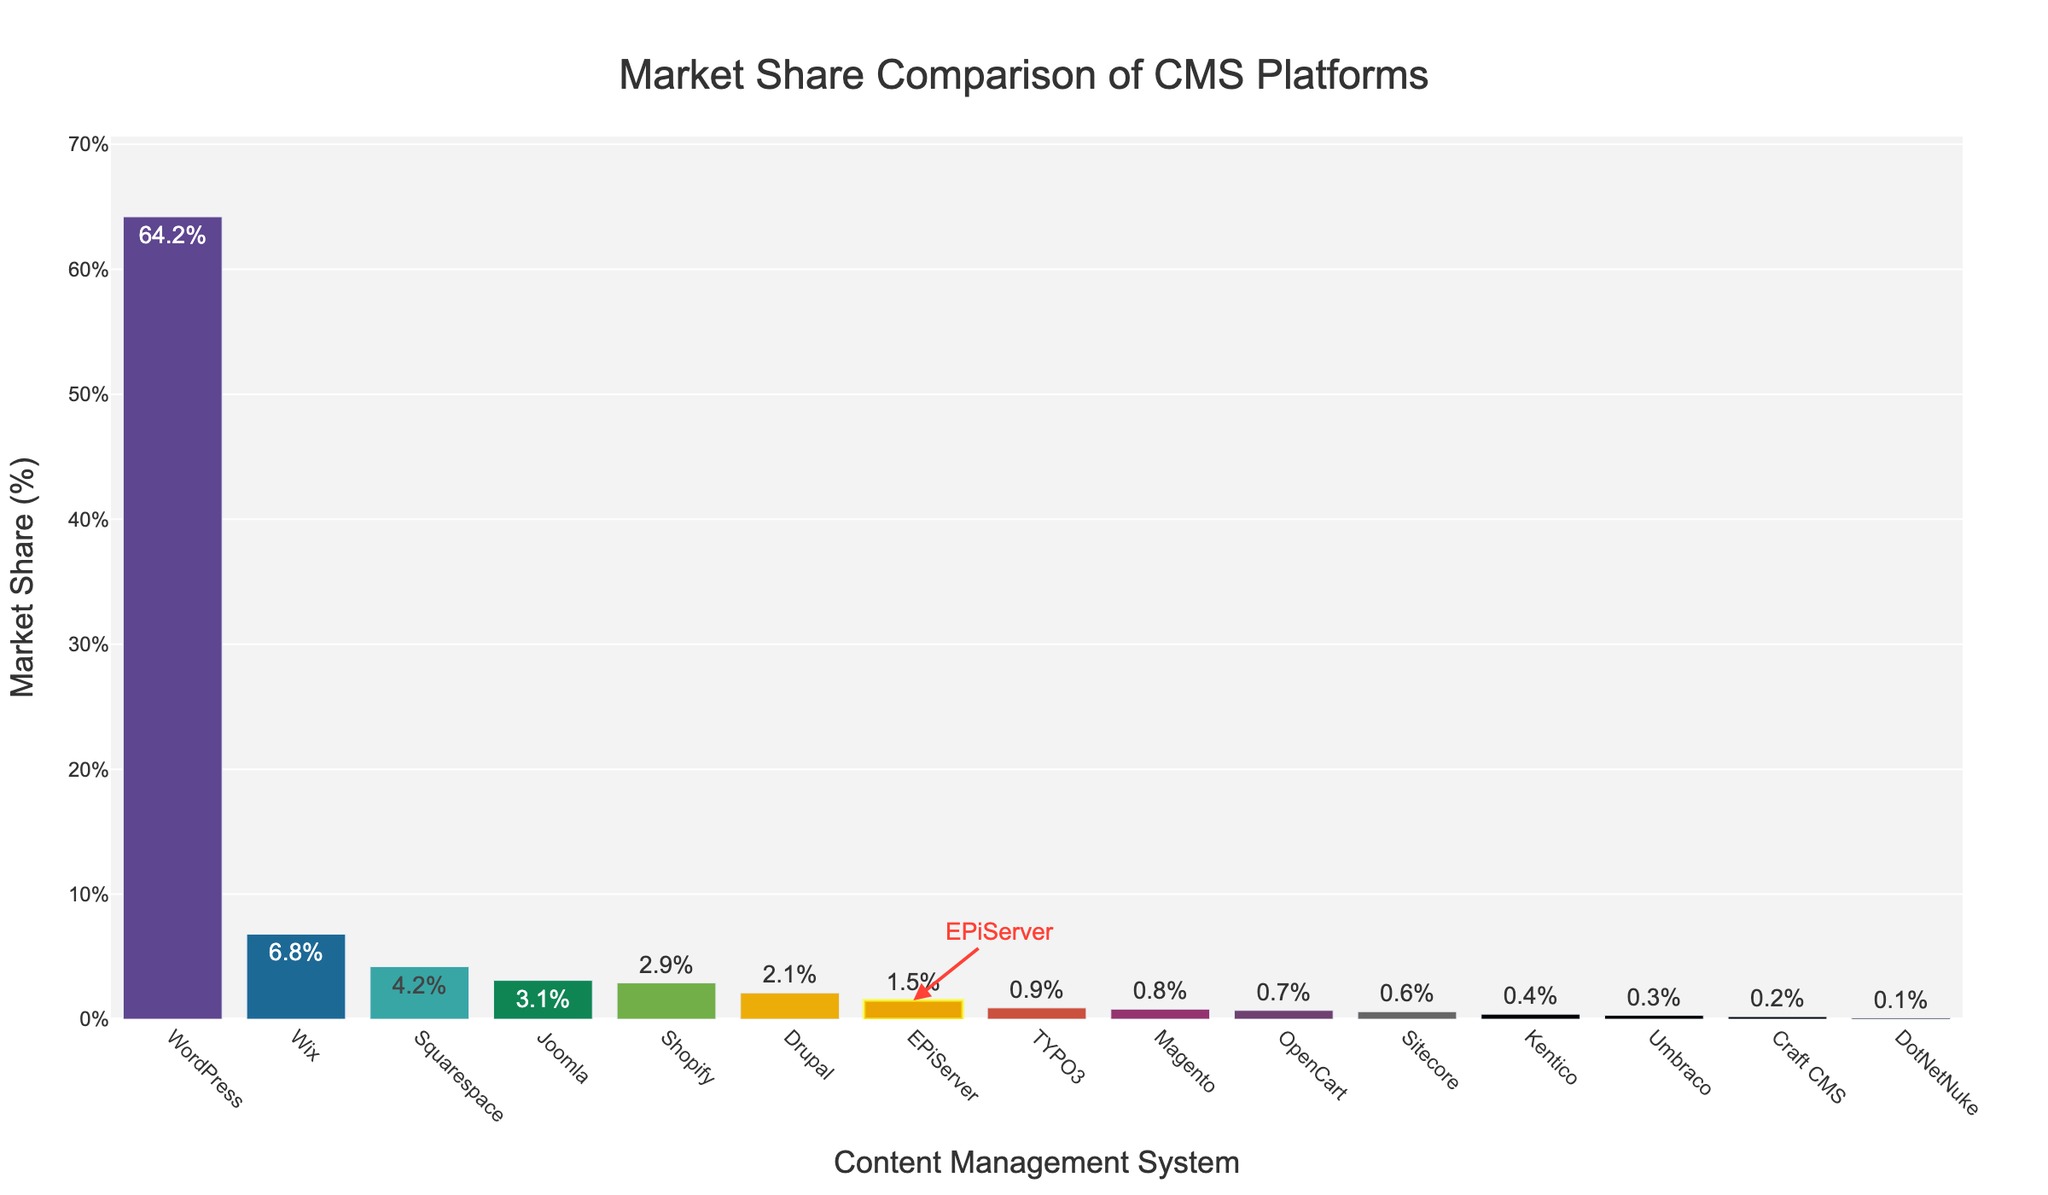What is the market share of WordPress compared to EPiServer? WordPress has a market share of 64.2% while EPiServer has a market share of 1.5%. Therefore, WordPress has a much larger market share compared to EPiServer.
Answer: WordPress has 64.2% and EPiServer has 1.5% Which CMS has the smallest market share and what is it? The CMS with the smallest market share is DotNetNuke with a market share of 0.1%.
Answer: DotNetNuke, 0.1% How many CMS platforms have a market share greater than EPiServer? To answer this, count the CMS platforms with a market share greater than 1.5%: WordPress, Wix, Squarespace, Joomla, Shopify, and Drupal. There are 6 such platforms.
Answer: 6 By what percentage does the market share of WordPress exceed the combined market share of EPiServer and Sitecore? The combined market share of EPiServer and Sitecore is 1.5% + 0.6% = 2.1%. WordPress has a market share of 64.2%. So, it exceeds by 64.2% - 2.1% = 62.1%.
Answer: 62.1% What is the combined market share of Joomla, Drupal, and Magento? Add the market shares of Joomla (3.1%), Drupal (2.1%), and Magento (0.8%): 3.1% + 2.1% + 0.8% = 6.0%.
Answer: 6.0% Which CMS platforms have a market share less than 1%? The CMS platforms with a market share less than 1% are TYPO3, Magento, OpenCart, Sitecore, Kentico, Umbraco, Craft CMS, and DotNetNuke.
Answer: TYPO3, Magento, OpenCart, Sitecore, Kentico, Umbraco, Craft CMS, DotNetNuke How much higher is the peak of the tallest bar compared to the peak of the shortest bar? The tallest bar (WordPress) has a peak at 64.2%, and the shortest bar (DotNetNuke) has a peak at 0.1%. The difference is 64.2% - 0.1% = 64.1%.
Answer: 64.1% Which CMS platforms have a market share between 1% and 3%, inclusive? The CMS platforms with a market share between 1% and 3% are EPiServer, TYPO3, Magento, and OpenCart.
Answer: EPiServer, TYPO3, Magento, OpenCart What color is the bar representing EPiServer? The bar for EPiServer is highlighted with a yellow rectangle and the text in red. The actual bar color belongs to the 'Prism' color scheme.
Answer: Yellow rectangle, red text, Prism bar color 